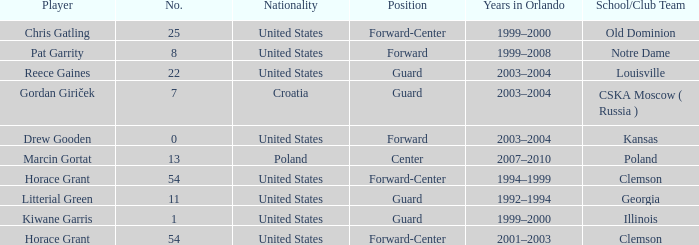How many players belong to Notre Dame? 1.0. 